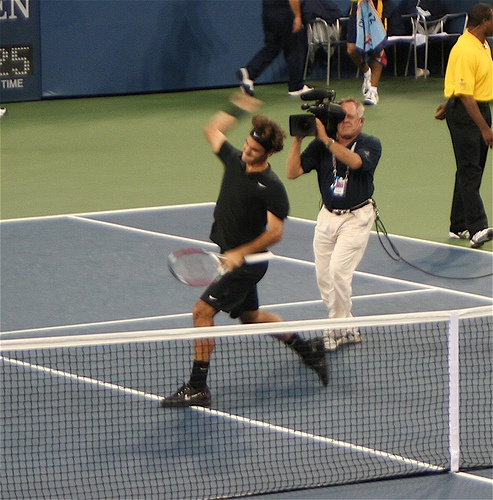Describe the objects in this image and their specific colors. I can see people in gray, black, and tan tones, people in gray, black, tan, and beige tones, people in gray, black, gold, and maroon tones, people in gray, black, maroon, and brown tones, and people in gray, black, darkgray, and maroon tones in this image. 